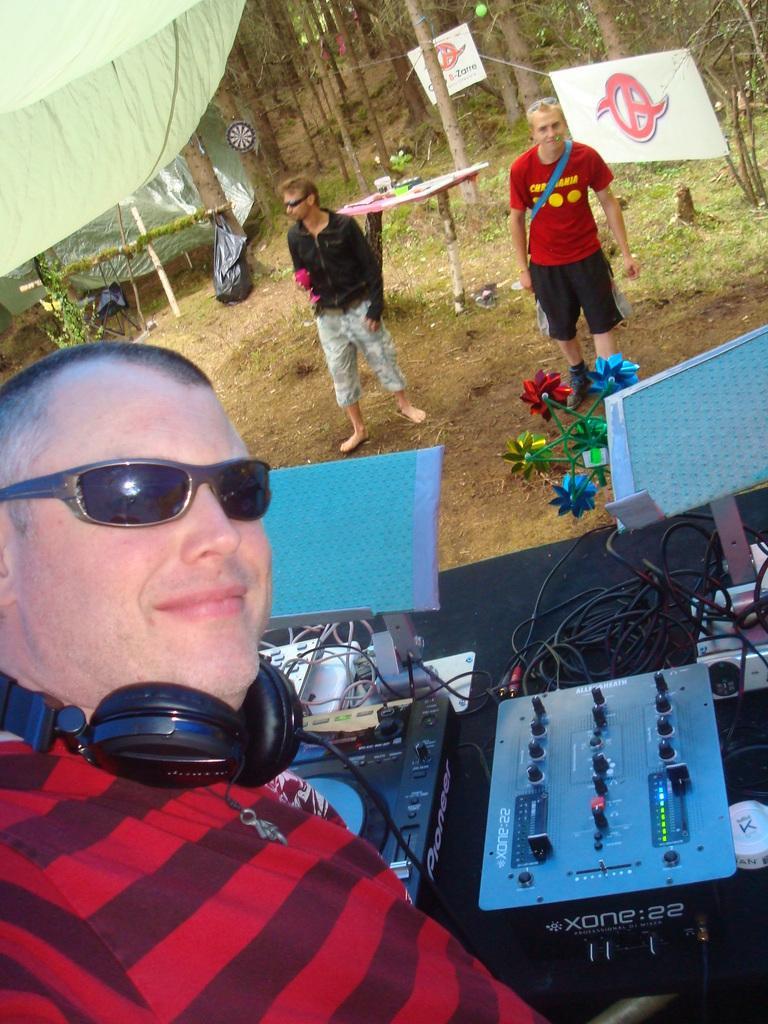Please provide a concise description of this image. This image consists of a man wearing red T-shirt is playing DJ. In the background, there are two men standing. And there are many trees. At the top, there is a tent. 